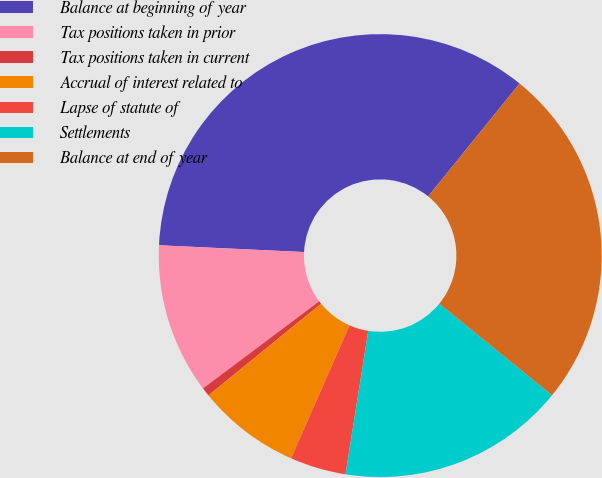Convert chart to OTSL. <chart><loc_0><loc_0><loc_500><loc_500><pie_chart><fcel>Balance at beginning of year<fcel>Tax positions taken in prior<fcel>Tax positions taken in current<fcel>Accrual of interest related to<fcel>Lapse of statute of<fcel>Settlements<fcel>Balance at end of year<nl><fcel>35.09%<fcel>10.98%<fcel>0.64%<fcel>7.53%<fcel>4.09%<fcel>16.64%<fcel>25.03%<nl></chart> 